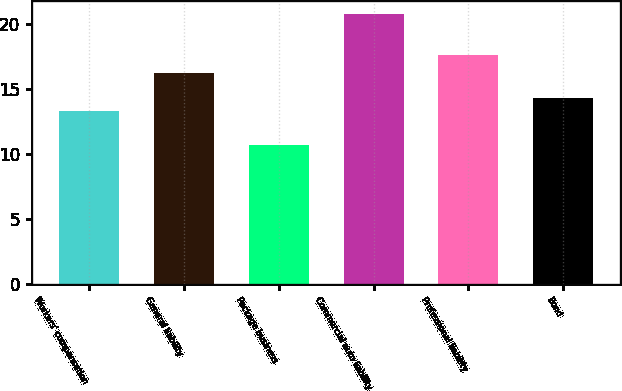Convert chart to OTSL. <chart><loc_0><loc_0><loc_500><loc_500><bar_chart><fcel>Workers' compensation<fcel>General liability<fcel>Package business<fcel>Commercial auto liability<fcel>Professional liability<fcel>Bond<nl><fcel>13.3<fcel>16.2<fcel>10.7<fcel>20.7<fcel>17.6<fcel>14.3<nl></chart> 